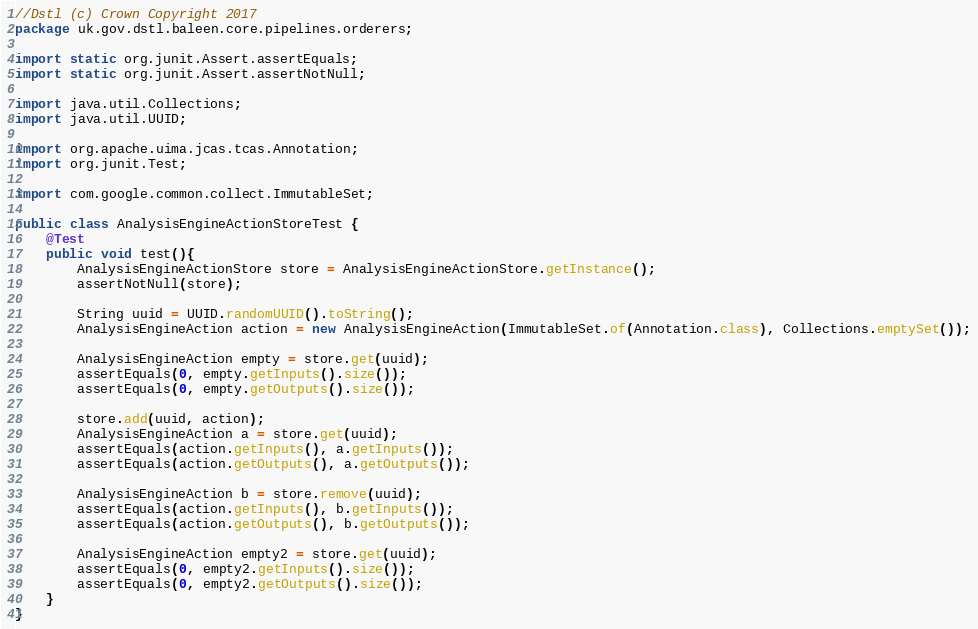Convert code to text. <code><loc_0><loc_0><loc_500><loc_500><_Java_>//Dstl (c) Crown Copyright 2017
package uk.gov.dstl.baleen.core.pipelines.orderers;

import static org.junit.Assert.assertEquals;
import static org.junit.Assert.assertNotNull;

import java.util.Collections;
import java.util.UUID;

import org.apache.uima.jcas.tcas.Annotation;
import org.junit.Test;

import com.google.common.collect.ImmutableSet;

public class AnalysisEngineActionStoreTest {
	@Test
	public void test(){
		AnalysisEngineActionStore store = AnalysisEngineActionStore.getInstance();
		assertNotNull(store);
		
		String uuid = UUID.randomUUID().toString();
		AnalysisEngineAction action = new AnalysisEngineAction(ImmutableSet.of(Annotation.class), Collections.emptySet());
		
		AnalysisEngineAction empty = store.get(uuid);
		assertEquals(0, empty.getInputs().size());
		assertEquals(0, empty.getOutputs().size());
		
		store.add(uuid, action);
		AnalysisEngineAction a = store.get(uuid);
		assertEquals(action.getInputs(), a.getInputs());
		assertEquals(action.getOutputs(), a.getOutputs());
		
		AnalysisEngineAction b = store.remove(uuid);
		assertEquals(action.getInputs(), b.getInputs());
		assertEquals(action.getOutputs(), b.getOutputs());
		
		AnalysisEngineAction empty2 = store.get(uuid);
		assertEquals(0, empty2.getInputs().size());
		assertEquals(0, empty2.getOutputs().size());
	}
}</code> 